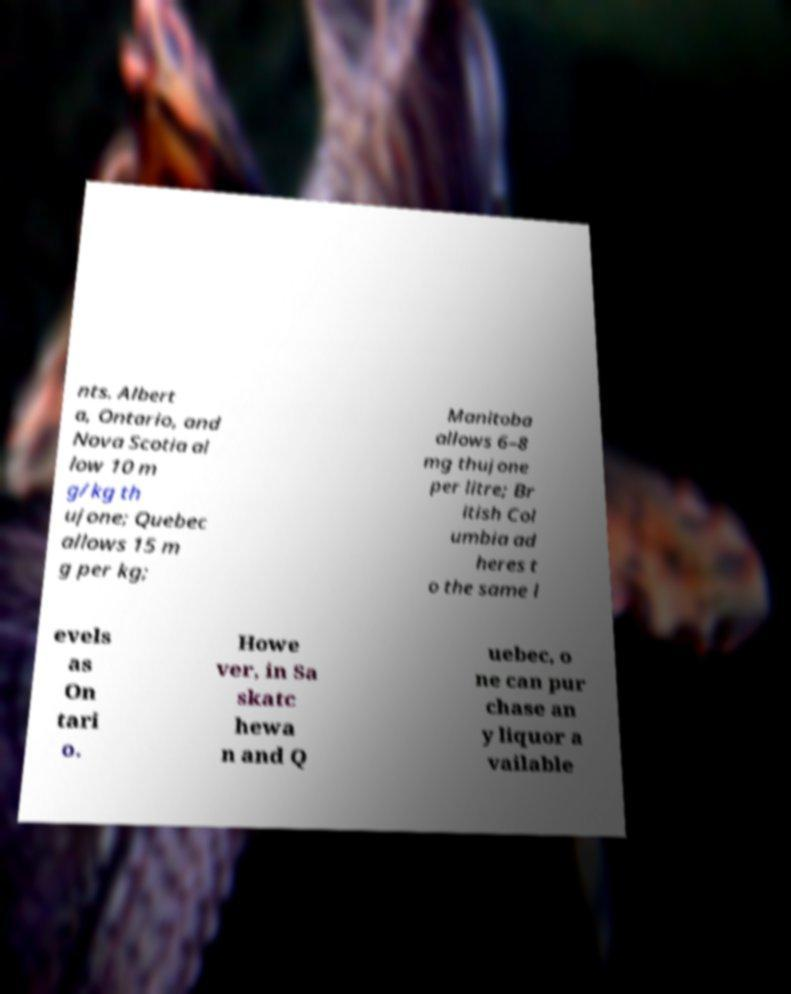What messages or text are displayed in this image? I need them in a readable, typed format. nts. Albert a, Ontario, and Nova Scotia al low 10 m g/kg th ujone; Quebec allows 15 m g per kg; Manitoba allows 6–8 mg thujone per litre; Br itish Col umbia ad heres t o the same l evels as On tari o. Howe ver, in Sa skatc hewa n and Q uebec, o ne can pur chase an y liquor a vailable 